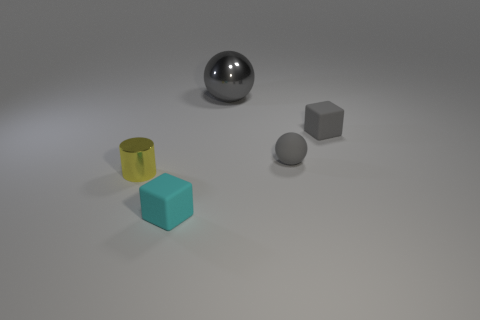Add 2 large brown rubber cubes. How many objects exist? 7 Subtract all spheres. How many objects are left? 3 Add 2 small blue shiny spheres. How many small blue shiny spheres exist? 2 Subtract 0 green balls. How many objects are left? 5 Subtract all gray matte cubes. Subtract all large metallic things. How many objects are left? 3 Add 3 tiny yellow objects. How many tiny yellow objects are left? 4 